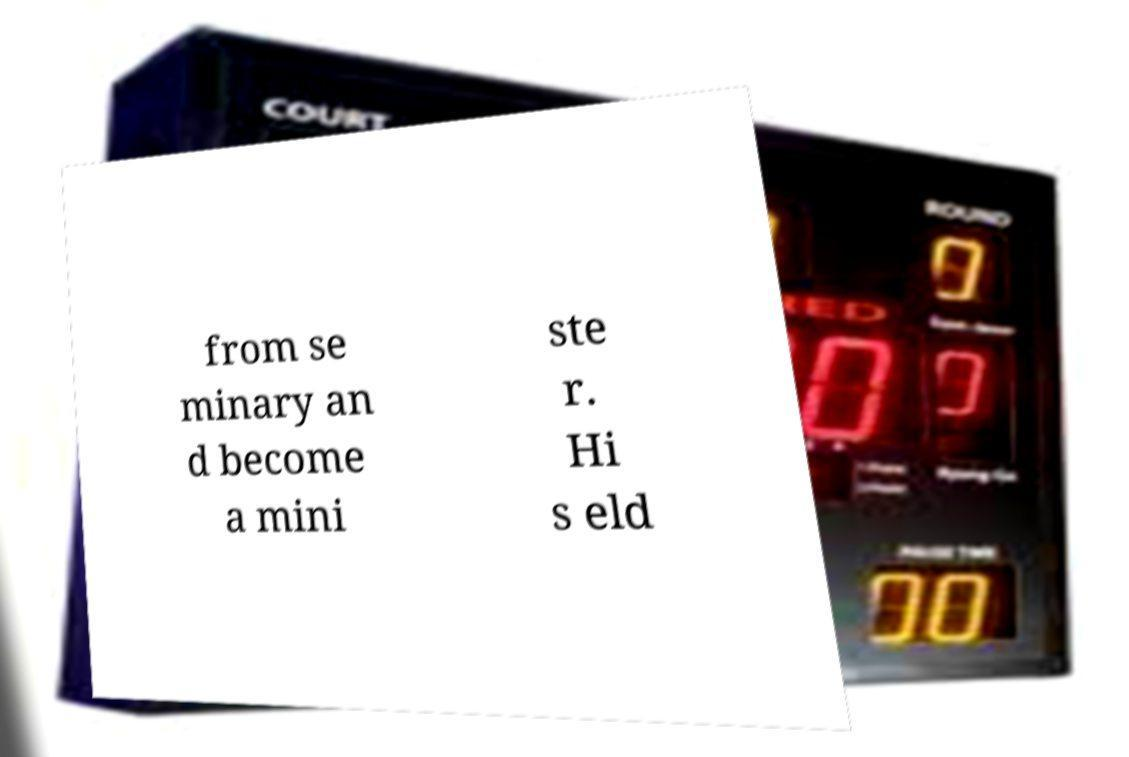Can you read and provide the text displayed in the image?This photo seems to have some interesting text. Can you extract and type it out for me? from se minary an d become a mini ste r. Hi s eld 